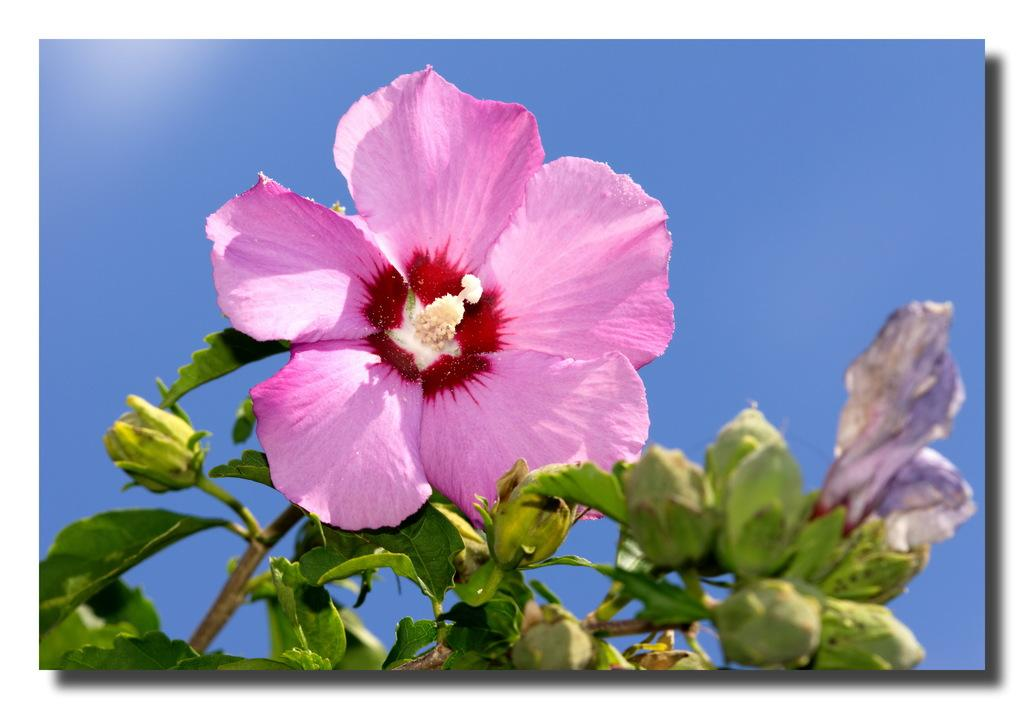What is the main subject of the image? There is a flower in the image. Can you describe the colors of the flower? The flower has pink, red, and white colors. What else can be seen in the image besides the flower? There are green leaves in the image. What is the color of the sky in the image? The sky is blue in the image. How much income does the flower generate in the image? There is no information about income in the image, as it features a flower and its surroundings. 